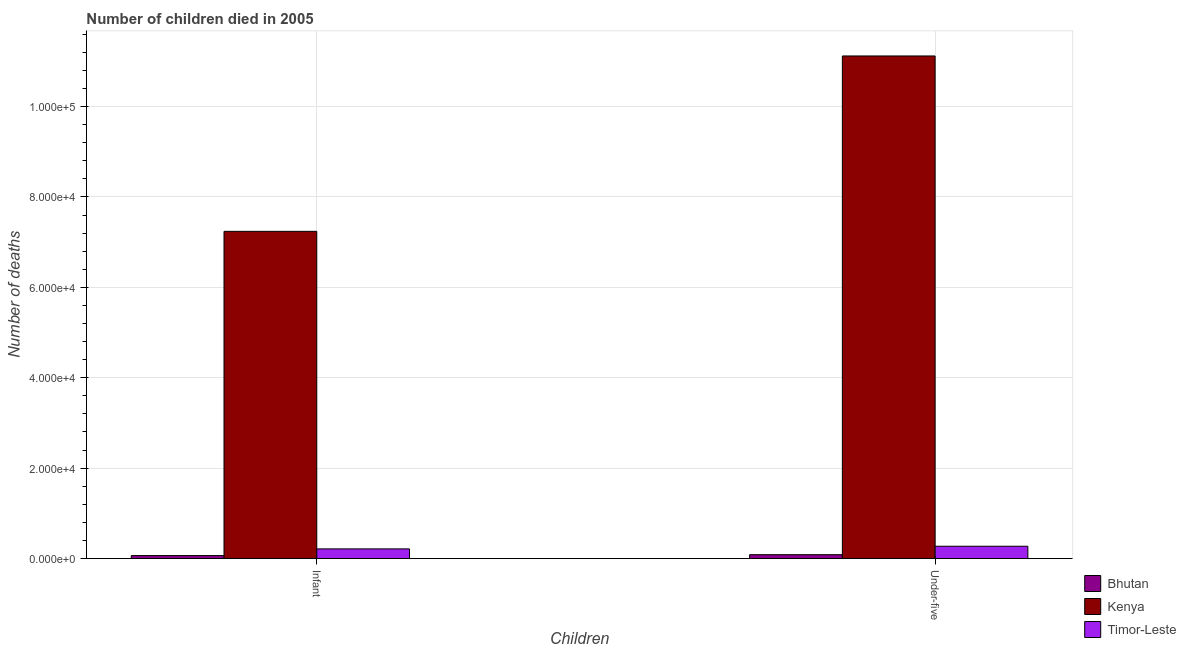How many different coloured bars are there?
Keep it short and to the point. 3. Are the number of bars on each tick of the X-axis equal?
Provide a succinct answer. Yes. How many bars are there on the 1st tick from the right?
Keep it short and to the point. 3. What is the label of the 1st group of bars from the left?
Give a very brief answer. Infant. What is the number of under-five deaths in Kenya?
Your answer should be compact. 1.11e+05. Across all countries, what is the maximum number of infant deaths?
Provide a short and direct response. 7.24e+04. Across all countries, what is the minimum number of under-five deaths?
Offer a terse response. 862. In which country was the number of infant deaths maximum?
Your response must be concise. Kenya. In which country was the number of infant deaths minimum?
Provide a succinct answer. Bhutan. What is the total number of infant deaths in the graph?
Provide a succinct answer. 7.52e+04. What is the difference between the number of under-five deaths in Bhutan and that in Kenya?
Offer a very short reply. -1.10e+05. What is the difference between the number of infant deaths in Bhutan and the number of under-five deaths in Timor-Leste?
Provide a short and direct response. -2066. What is the average number of under-five deaths per country?
Provide a short and direct response. 3.83e+04. What is the difference between the number of under-five deaths and number of infant deaths in Bhutan?
Your answer should be compact. 200. In how many countries, is the number of infant deaths greater than 32000 ?
Provide a short and direct response. 1. What is the ratio of the number of infant deaths in Bhutan to that in Timor-Leste?
Provide a succinct answer. 0.31. Is the number of infant deaths in Timor-Leste less than that in Kenya?
Ensure brevity in your answer.  Yes. What does the 2nd bar from the left in Infant represents?
Your answer should be compact. Kenya. What does the 1st bar from the right in Infant represents?
Give a very brief answer. Timor-Leste. Are all the bars in the graph horizontal?
Keep it short and to the point. No. How many countries are there in the graph?
Offer a very short reply. 3. What is the difference between two consecutive major ticks on the Y-axis?
Your answer should be compact. 2.00e+04. Are the values on the major ticks of Y-axis written in scientific E-notation?
Your answer should be very brief. Yes. Does the graph contain any zero values?
Your answer should be very brief. No. Where does the legend appear in the graph?
Provide a short and direct response. Bottom right. How many legend labels are there?
Offer a terse response. 3. How are the legend labels stacked?
Your answer should be very brief. Vertical. What is the title of the graph?
Keep it short and to the point. Number of children died in 2005. Does "Spain" appear as one of the legend labels in the graph?
Your answer should be very brief. No. What is the label or title of the X-axis?
Ensure brevity in your answer.  Children. What is the label or title of the Y-axis?
Provide a succinct answer. Number of deaths. What is the Number of deaths in Bhutan in Infant?
Your response must be concise. 662. What is the Number of deaths of Kenya in Infant?
Offer a very short reply. 7.24e+04. What is the Number of deaths in Timor-Leste in Infant?
Ensure brevity in your answer.  2140. What is the Number of deaths of Bhutan in Under-five?
Your answer should be compact. 862. What is the Number of deaths of Kenya in Under-five?
Ensure brevity in your answer.  1.11e+05. What is the Number of deaths of Timor-Leste in Under-five?
Your answer should be compact. 2728. Across all Children, what is the maximum Number of deaths of Bhutan?
Keep it short and to the point. 862. Across all Children, what is the maximum Number of deaths of Kenya?
Provide a succinct answer. 1.11e+05. Across all Children, what is the maximum Number of deaths in Timor-Leste?
Keep it short and to the point. 2728. Across all Children, what is the minimum Number of deaths in Bhutan?
Provide a short and direct response. 662. Across all Children, what is the minimum Number of deaths of Kenya?
Provide a succinct answer. 7.24e+04. Across all Children, what is the minimum Number of deaths in Timor-Leste?
Ensure brevity in your answer.  2140. What is the total Number of deaths in Bhutan in the graph?
Ensure brevity in your answer.  1524. What is the total Number of deaths in Kenya in the graph?
Provide a succinct answer. 1.84e+05. What is the total Number of deaths in Timor-Leste in the graph?
Your answer should be compact. 4868. What is the difference between the Number of deaths in Bhutan in Infant and that in Under-five?
Your answer should be compact. -200. What is the difference between the Number of deaths in Kenya in Infant and that in Under-five?
Provide a succinct answer. -3.88e+04. What is the difference between the Number of deaths of Timor-Leste in Infant and that in Under-five?
Give a very brief answer. -588. What is the difference between the Number of deaths in Bhutan in Infant and the Number of deaths in Kenya in Under-five?
Make the answer very short. -1.11e+05. What is the difference between the Number of deaths of Bhutan in Infant and the Number of deaths of Timor-Leste in Under-five?
Your answer should be compact. -2066. What is the difference between the Number of deaths in Kenya in Infant and the Number of deaths in Timor-Leste in Under-five?
Provide a succinct answer. 6.97e+04. What is the average Number of deaths in Bhutan per Children?
Your answer should be compact. 762. What is the average Number of deaths in Kenya per Children?
Your response must be concise. 9.18e+04. What is the average Number of deaths of Timor-Leste per Children?
Your response must be concise. 2434. What is the difference between the Number of deaths in Bhutan and Number of deaths in Kenya in Infant?
Provide a succinct answer. -7.17e+04. What is the difference between the Number of deaths of Bhutan and Number of deaths of Timor-Leste in Infant?
Provide a short and direct response. -1478. What is the difference between the Number of deaths of Kenya and Number of deaths of Timor-Leste in Infant?
Offer a very short reply. 7.03e+04. What is the difference between the Number of deaths in Bhutan and Number of deaths in Kenya in Under-five?
Your response must be concise. -1.10e+05. What is the difference between the Number of deaths of Bhutan and Number of deaths of Timor-Leste in Under-five?
Ensure brevity in your answer.  -1866. What is the difference between the Number of deaths in Kenya and Number of deaths in Timor-Leste in Under-five?
Your answer should be compact. 1.08e+05. What is the ratio of the Number of deaths in Bhutan in Infant to that in Under-five?
Keep it short and to the point. 0.77. What is the ratio of the Number of deaths of Kenya in Infant to that in Under-five?
Keep it short and to the point. 0.65. What is the ratio of the Number of deaths in Timor-Leste in Infant to that in Under-five?
Your answer should be compact. 0.78. What is the difference between the highest and the second highest Number of deaths in Bhutan?
Keep it short and to the point. 200. What is the difference between the highest and the second highest Number of deaths in Kenya?
Provide a short and direct response. 3.88e+04. What is the difference between the highest and the second highest Number of deaths in Timor-Leste?
Your answer should be compact. 588. What is the difference between the highest and the lowest Number of deaths of Bhutan?
Your response must be concise. 200. What is the difference between the highest and the lowest Number of deaths of Kenya?
Provide a short and direct response. 3.88e+04. What is the difference between the highest and the lowest Number of deaths of Timor-Leste?
Offer a terse response. 588. 